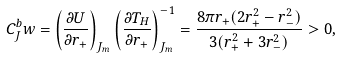Convert formula to latex. <formula><loc_0><loc_0><loc_500><loc_500>C _ { J } ^ { b } w = \left ( \frac { \partial U } { \partial r _ { + } } \right ) _ { J _ { m } } \left ( \frac { \partial T _ { H } } { \partial r _ { + } } \right ) _ { J _ { m } } ^ { - 1 } = \frac { 8 \pi r _ { + } ( 2 r _ { + } ^ { 2 } - r _ { - } ^ { 2 } ) } { 3 ( r _ { + } ^ { 2 } + 3 r _ { - } ^ { 2 } ) } > 0 ,</formula> 